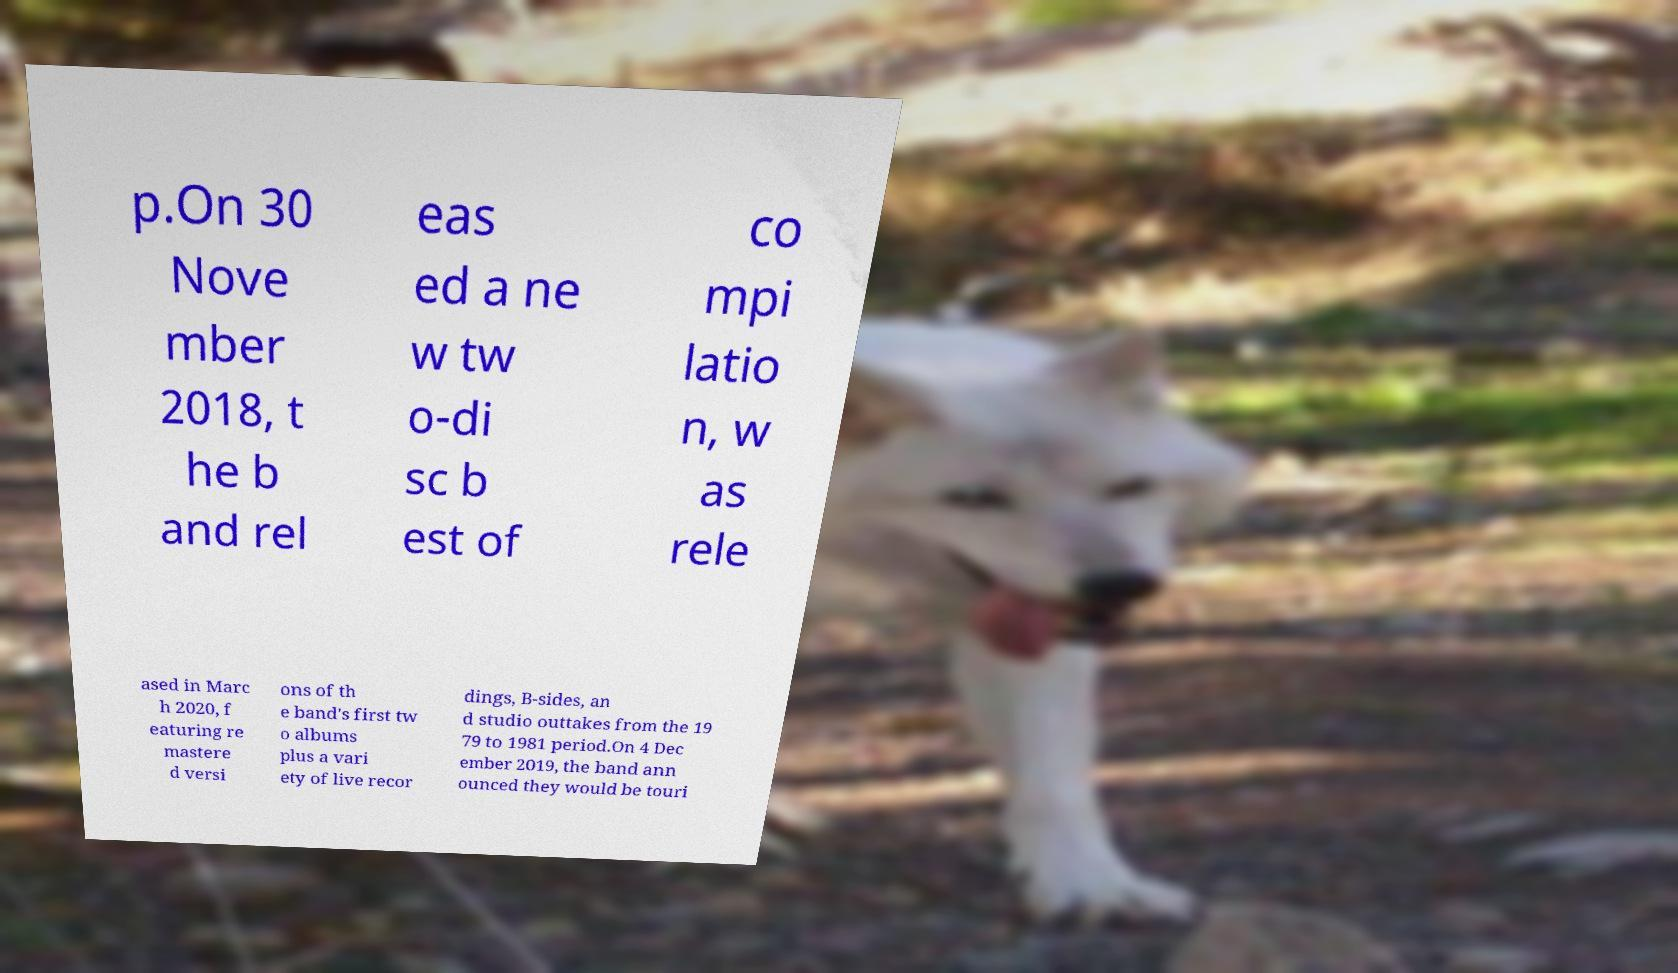Please identify and transcribe the text found in this image. p.On 30 Nove mber 2018, t he b and rel eas ed a ne w tw o-di sc b est of co mpi latio n, w as rele ased in Marc h 2020, f eaturing re mastere d versi ons of th e band's first tw o albums plus a vari ety of live recor dings, B-sides, an d studio outtakes from the 19 79 to 1981 period.On 4 Dec ember 2019, the band ann ounced they would be touri 